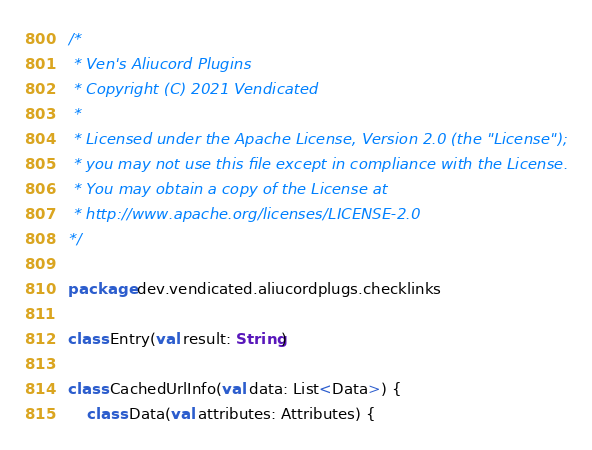Convert code to text. <code><loc_0><loc_0><loc_500><loc_500><_Kotlin_>/*
 * Ven's Aliucord Plugins
 * Copyright (C) 2021 Vendicated
 *
 * Licensed under the Apache License, Version 2.0 (the "License");
 * you may not use this file except in compliance with the License.
 * You may obtain a copy of the License at 
 * http://www.apache.org/licenses/LICENSE-2.0
*/

package dev.vendicated.aliucordplugs.checklinks

class Entry(val result: String)

class CachedUrlInfo(val data: List<Data>) {
    class Data(val attributes: Attributes) {</code> 